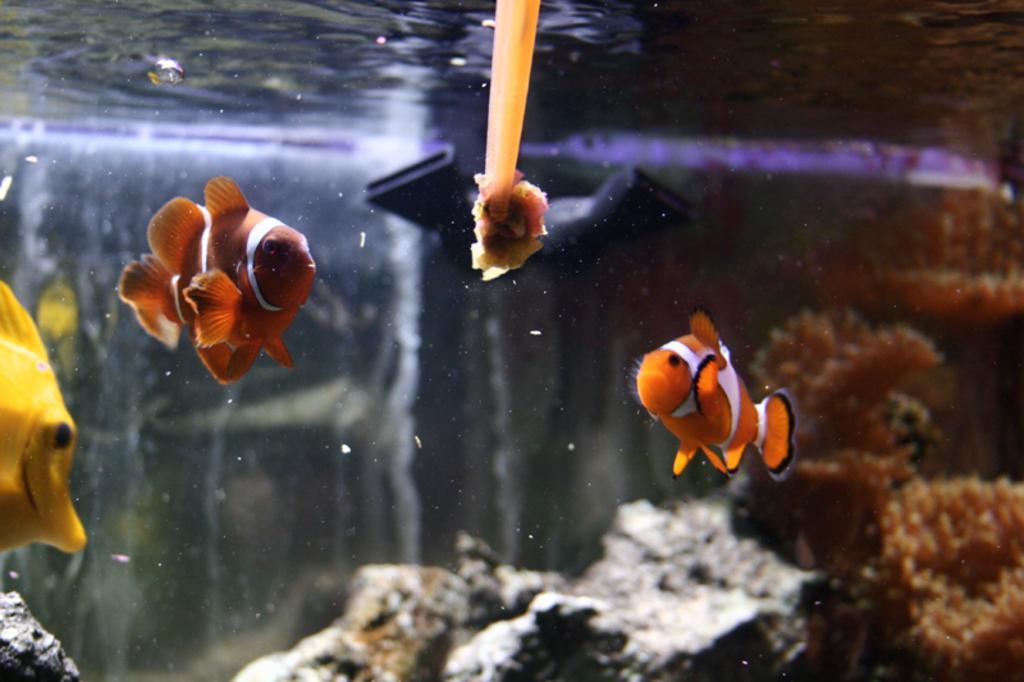Can you describe this image briefly? In the picture there are fishes present in the water, there are marine plants present in the water. 